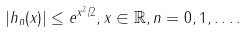Convert formula to latex. <formula><loc_0><loc_0><loc_500><loc_500>| h _ { n } ( x ) | \leq e ^ { x ^ { 2 } / 2 } , x \in \mathbb { R } , n = 0 , 1 , \dots .</formula> 